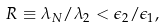Convert formula to latex. <formula><loc_0><loc_0><loc_500><loc_500>R \equiv \lambda _ { N } / \lambda _ { 2 } < \epsilon _ { 2 } / \epsilon _ { 1 } ,</formula> 